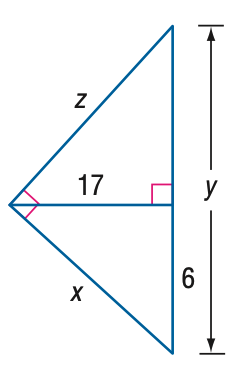Answer the mathemtical geometry problem and directly provide the correct option letter.
Question: Find z.
Choices: A: 17 B: \frac { 17 } { 6 } \sqrt { 253 } C: \frac { 289 } { 6 } D: \frac { 85 } { 6 } \sqrt { 13 } D 